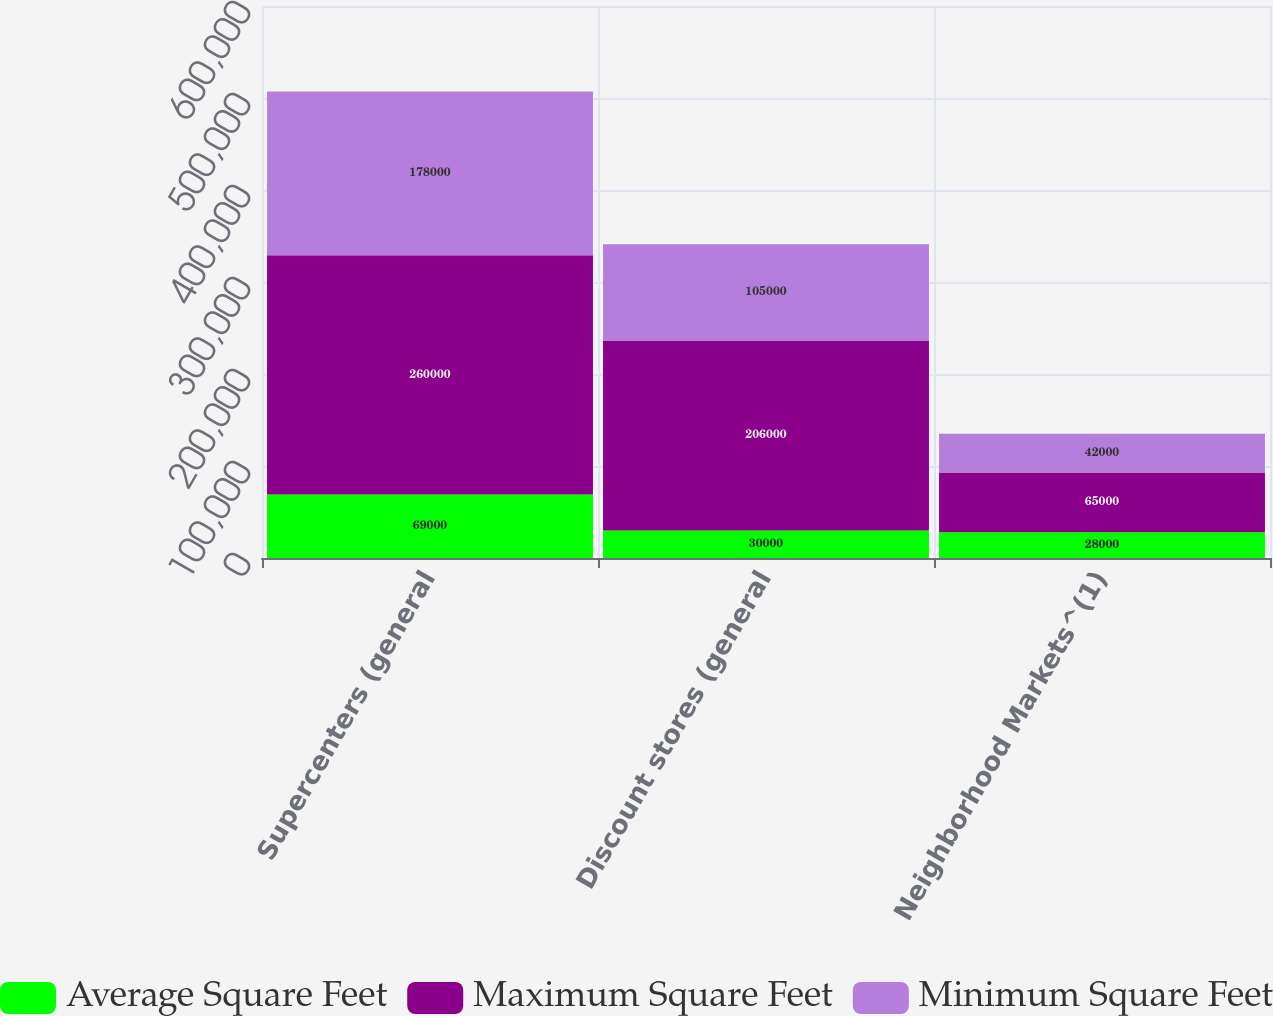Convert chart to OTSL. <chart><loc_0><loc_0><loc_500><loc_500><stacked_bar_chart><ecel><fcel>Supercenters (general<fcel>Discount stores (general<fcel>Neighborhood Markets^(1)<nl><fcel>Average Square Feet<fcel>69000<fcel>30000<fcel>28000<nl><fcel>Maximum Square Feet<fcel>260000<fcel>206000<fcel>65000<nl><fcel>Minimum Square Feet<fcel>178000<fcel>105000<fcel>42000<nl></chart> 